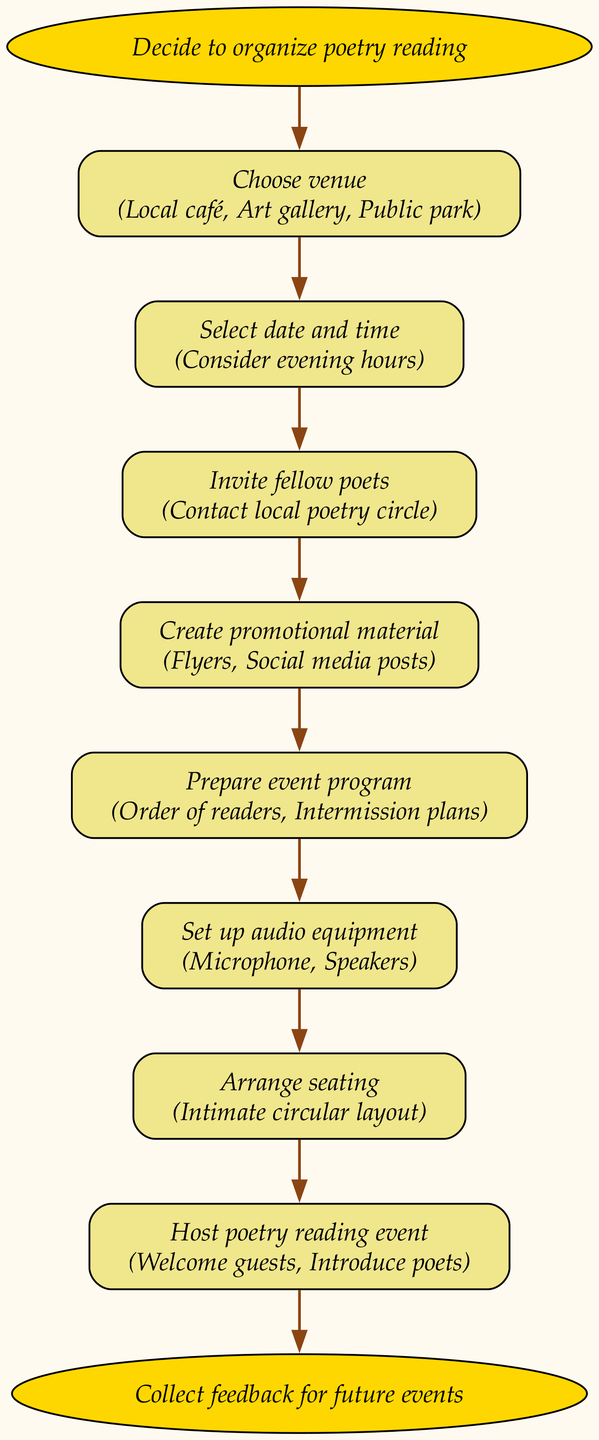What is the first step to organize a poetry reading event? The first node or step in the flow chart clearly states "Decide to organize poetry reading," which indicates it's the starting point.
Answer: Decide to organize poetry reading How many steps are involved in organizing the event? By counting the "steps" section in the diagram, we can identify there are 7 individual steps listed that are necessary to organize the poetry reading event.
Answer: 7 What is the last step in the process? The end node of the flow chart indicates the conclusion with the phrase "Collect feedback for future events," showing the last action that occurs after hosting the event.
Answer: Collect feedback for future events What types of venues can be chosen according to the flow chart? In the "Choose venue" step, the diagram lists three options: "Local café," "Art gallery," and "Public park," giving a clear overview of venue choices.
Answer: Local café, Art gallery, Public park Which step involves creating promotional material? The diagram highlights a specific step labeled "Create promotional material," explicitly pointing to this task related to marketing the event.
Answer: Create promotional material What audio equipment is mentioned for the event? The step "Set up audio equipment" mentions two specific items necessary for the event: "Microphone" and "Speakers," indicating what is required for sound setup.
Answer: Microphone, Speakers What is the seating arrangement style suggested in the flow chart? The step on "Arrange seating" describes the seating style as "Intimate circular layout," providing insight into how the seating should be organized for the event.
Answer: Intimate circular layout How are fellow poets invited to the event? The flow chart indicates in the step "Invite fellow poets" that the action required is to "Contact local poetry circle," showing the method of invitation.
Answer: Contact local poetry circle What activities should be performed during the poetry reading event? In the last step "Host poetry reading event," two specific activities are mentioned: "Welcome guests" and "Introduce poets," clarifying what hosts should do during the event.
Answer: Welcome guests, Introduce poets 